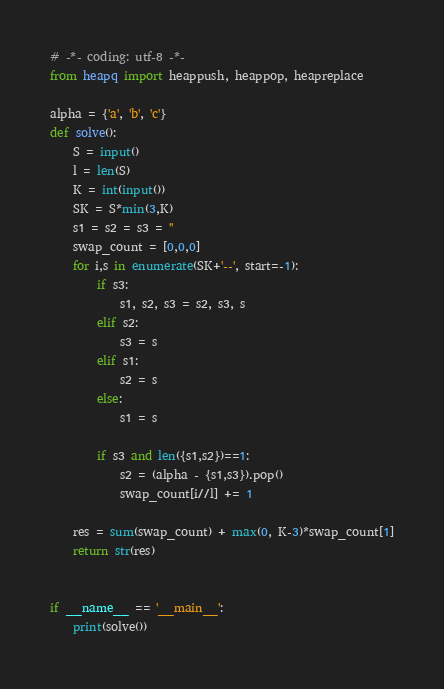Convert code to text. <code><loc_0><loc_0><loc_500><loc_500><_Python_># -*- coding: utf-8 -*-
from heapq import heappush, heappop, heapreplace

alpha = {'a', 'b', 'c'}
def solve():
    S = input()
    l = len(S)
    K = int(input())
    SK = S*min(3,K)
    s1 = s2 = s3 = ''
    swap_count = [0,0,0]
    for i,s in enumerate(SK+'--', start=-1):
        if s3:
            s1, s2, s3 = s2, s3, s
        elif s2:
            s3 = s
        elif s1:
            s2 = s
        else:
            s1 = s

        if s3 and len({s1,s2})==1:
            s2 = (alpha - {s1,s3}).pop()
            swap_count[i//l] += 1

    res = sum(swap_count) + max(0, K-3)*swap_count[1]
    return str(res)
    

if __name__ == '__main__':
    print(solve())
</code> 